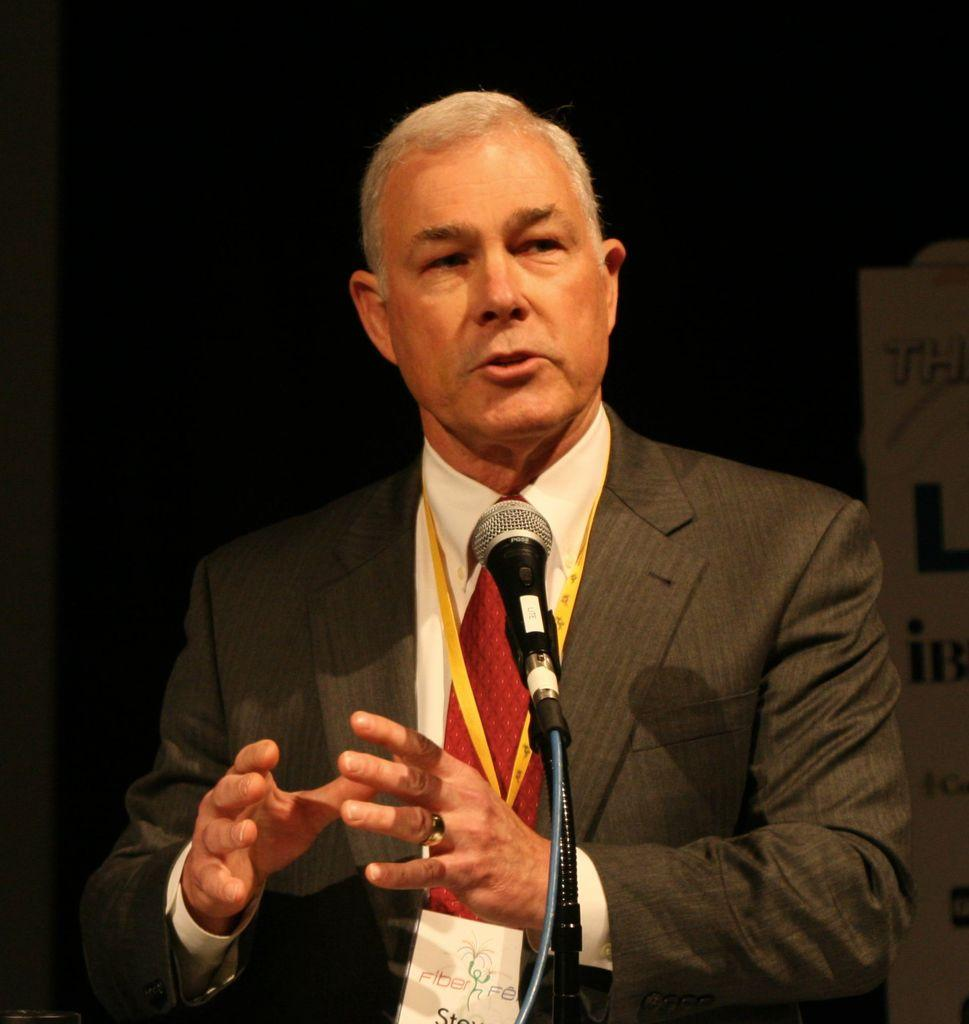What is the main subject of the image? There is a man in the image. What is the man holding in the image? The man is holding a microphone. What type of act is the man performing in the image? There is no indication of a performance or act in the image; the man is simply holding a microphone. Is there a flame visible in the image? No, there is no flame present in the image. 